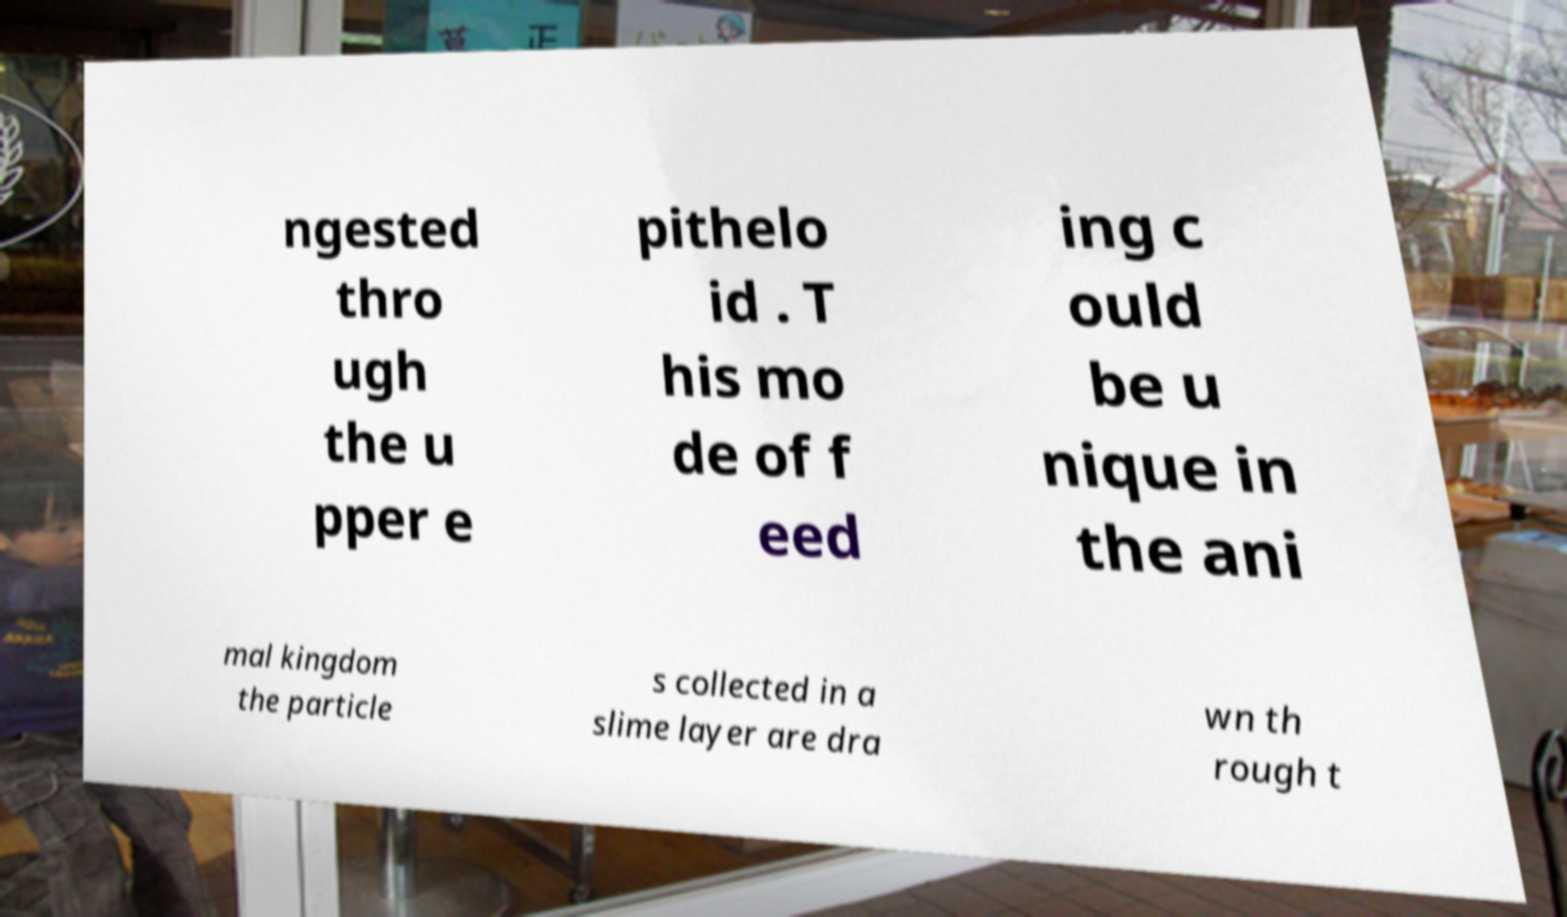I need the written content from this picture converted into text. Can you do that? ngested thro ugh the u pper e pithelo id . T his mo de of f eed ing c ould be u nique in the ani mal kingdom the particle s collected in a slime layer are dra wn th rough t 